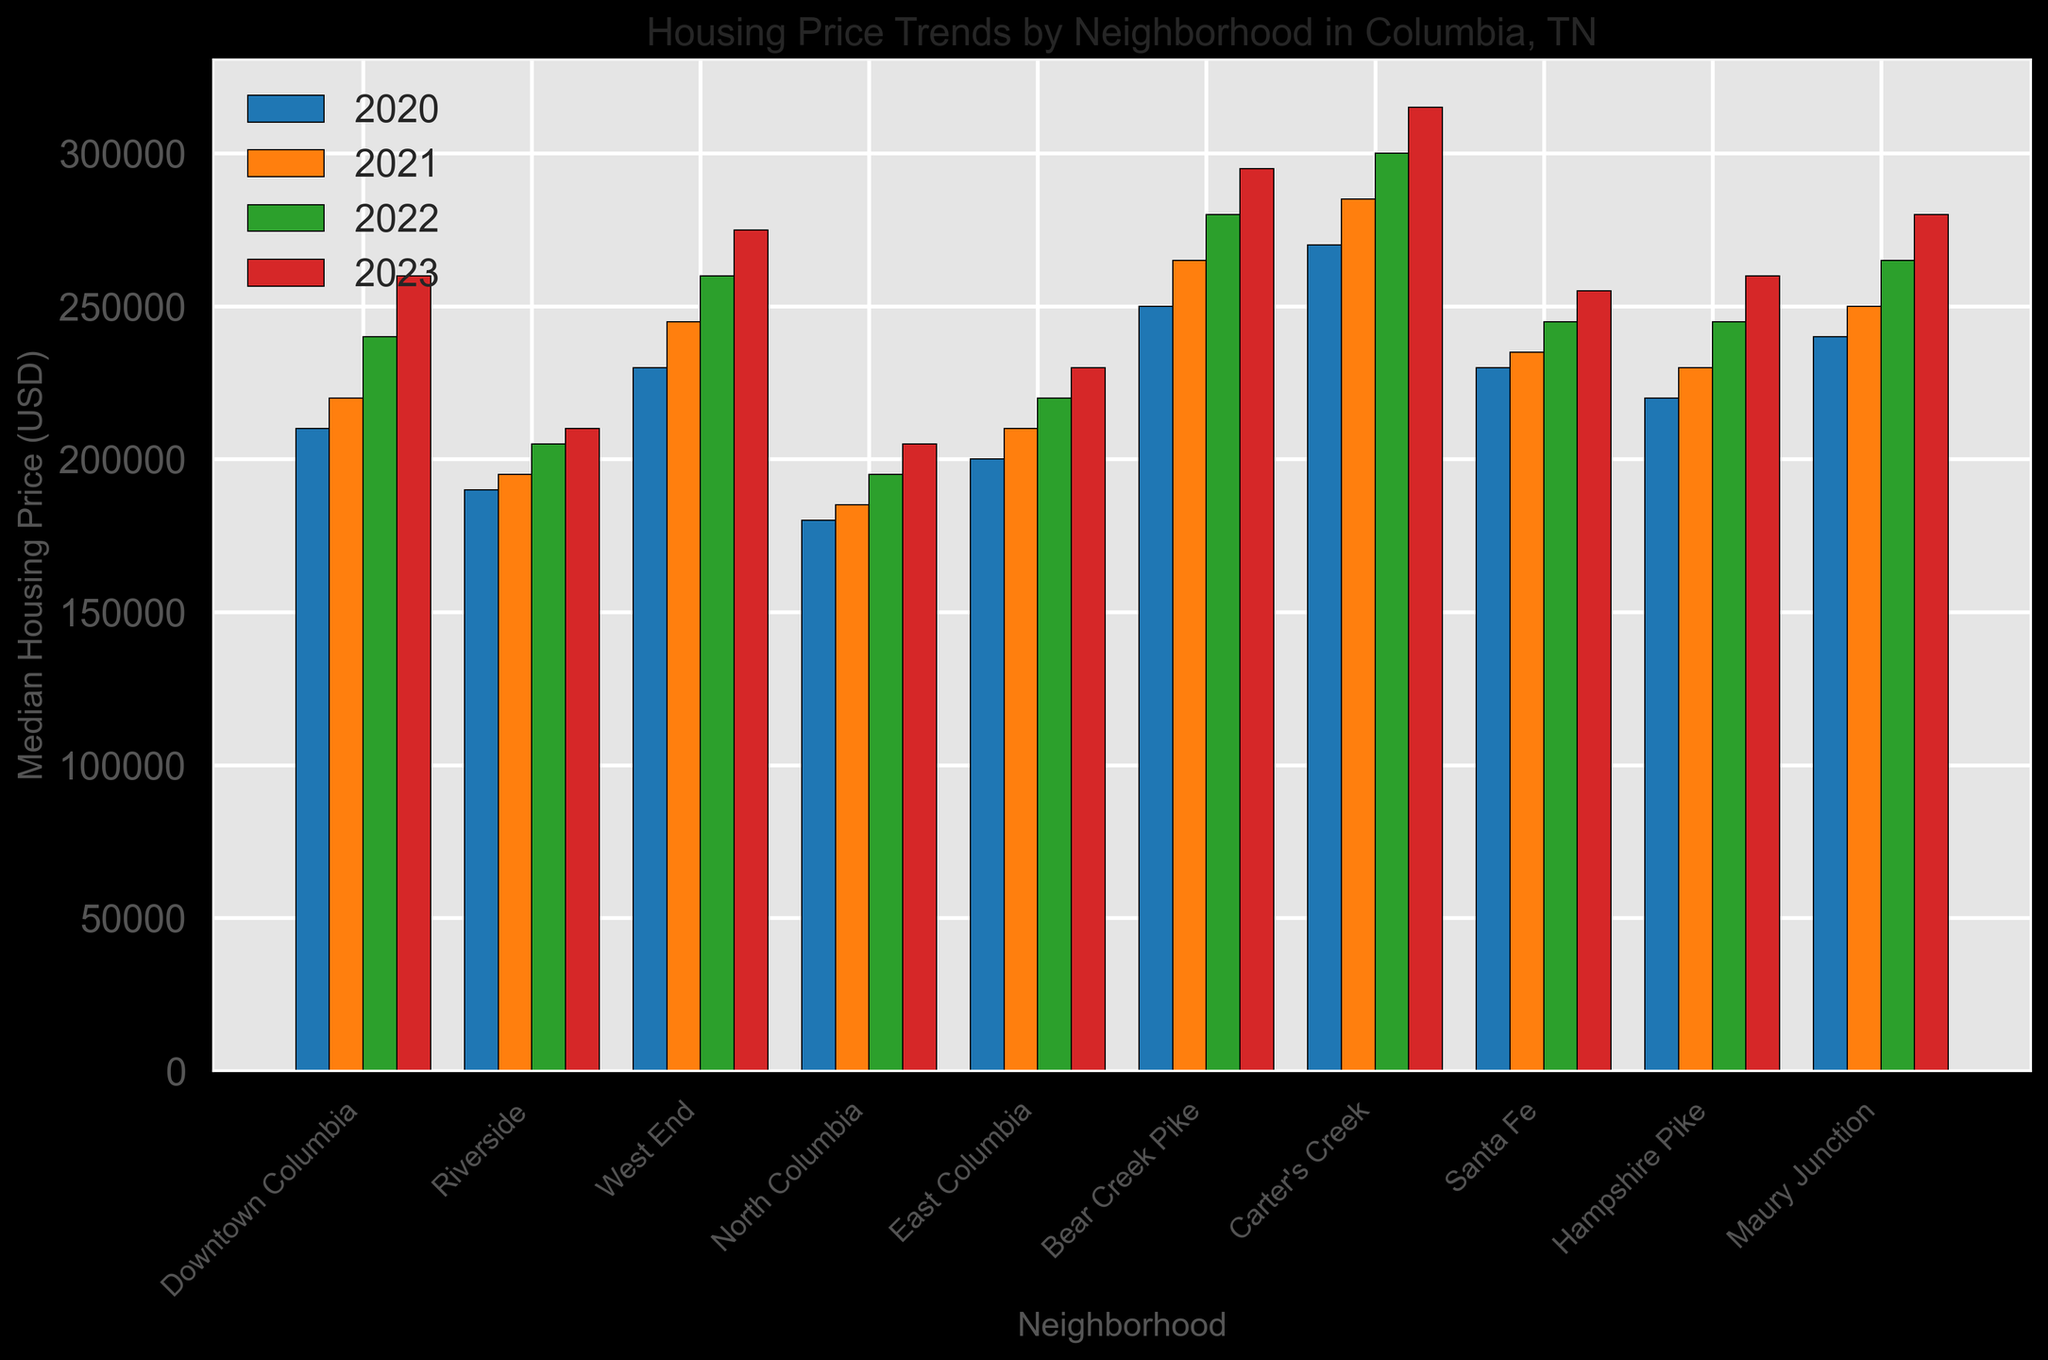What is the median housing price for Downtown Columbia in 2023? To find this, look at the bar representing Downtown Columbia in the 2023 section of the bar chart, noting the value associated with the top of the bar
Answer: 260,000 Which neighborhood had the highest median housing price in 2020? Identify the tallest bar in the 2020 section of the bar chart and note the neighborhood it corresponds to
Answer: Carter's Creek How much did the median housing price in Riverside increase from 2020 to 2023? Find Riverside in the bar chart, note the values for 2020 and 2023, then subtract the 2020 value from the 2023 value: 210,000 - 190,000
Answer: 20,000 Which neighborhood had the smallest increase in median housing price from 2022 to 2023? Compare the heights of the bars for each neighborhood between 2022 and 2023, finding the neighborhood where the increase is the least
Answer: Riverside What is the average median housing price in 2022 for all neighborhoods? Add the 2022 median prices for all neighborhoods and divide by the number of neighborhoods (10): (240,000 + 205,000 + 260,000 + 195,000 + 220,000 + 280,000 + 300,000 + 245,000 + 245,000 + 265,000) / 10
Answer: 245,500 Which neighborhood had the most consistent median housing price trend from 2020 to 2023? Identify the neighborhood whose bars show the smallest year-to-year change by visually comparing the heights of the bars for each year
Answer: East Columbia How did the median housing prices in West End compare to North Columbia in 2021? Look at the bars for West End and North Columbia for the year 2021 and compare their heights or values
Answer: West End: 245,000, North Columbia: 185,000 Which two neighborhoods had the exact same median housing price in the year 2023? Find pairs of bars in the 2023 section that reach the same height and correspond to the same value
Answer: Santa Fe, Hampshire Pike What is the overall trend in median housing prices from 2020 to 2023 across all neighborhoods? Observe the general direction of the bars' heights from 2020 to 2023 for all neighborhoods to determine if they are increasing, decreasing, or stable
Answer: Increasing 